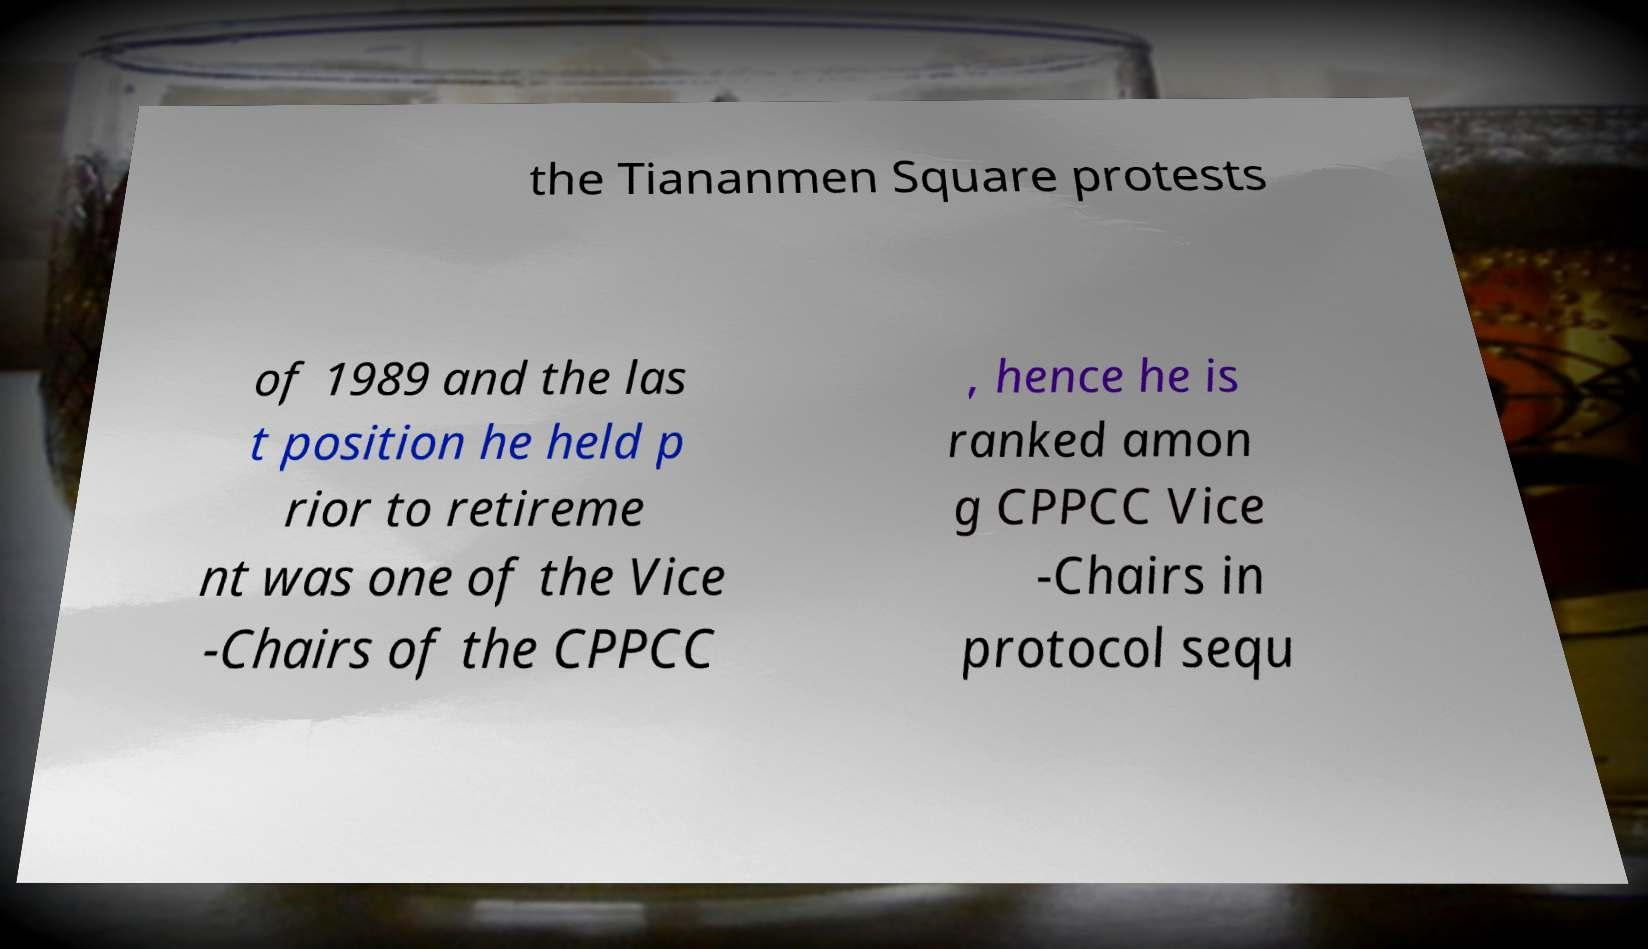Please identify and transcribe the text found in this image. the Tiananmen Square protests of 1989 and the las t position he held p rior to retireme nt was one of the Vice -Chairs of the CPPCC , hence he is ranked amon g CPPCC Vice -Chairs in protocol sequ 